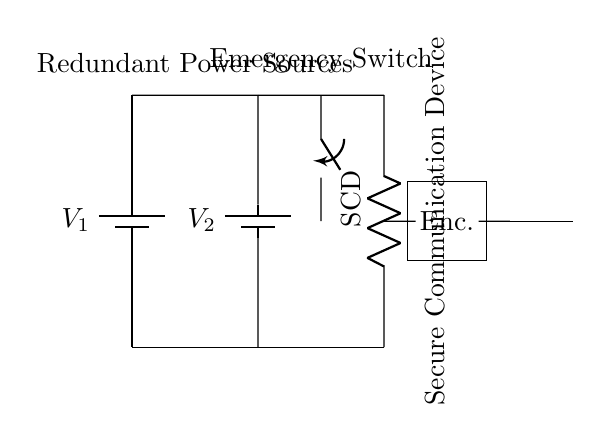What are the voltage sources in the circuit? The circuit includes two batteries labeled V1 and V2, which serve as the voltage sources.
Answer: V1, V2 How are the voltage sources connected? The batteries V1 and V2 are connected in parallel, as indicated by the short connections at the top of the circuit diagram.
Answer: Parallel What is the purpose of the emergency switch? The switch in the circuit allows the user to control the flow of power to the secure communication device, providing a manual means to maintain or cut off power during emergencies.
Answer: Control power What type of load is represented in the circuit? The load in the circuit is labeled SCD, which stands for Secure Communication Device, indicating its primary function.
Answer: Secure Communication Device Why is redundancy important in this circuit? Redundancy through dual power sources (V1 and V2) ensures that if one power source fails, the other can continue to supply power, thus maintaining the functionality of the secure communication device.
Answer: Reliability How does the encryption component connect to the secure communication device? The encryption component is connected directly below the secure communication device, with a short connection established between them, indicating it processes the communication output before transmission.
Answer: Direct connection 